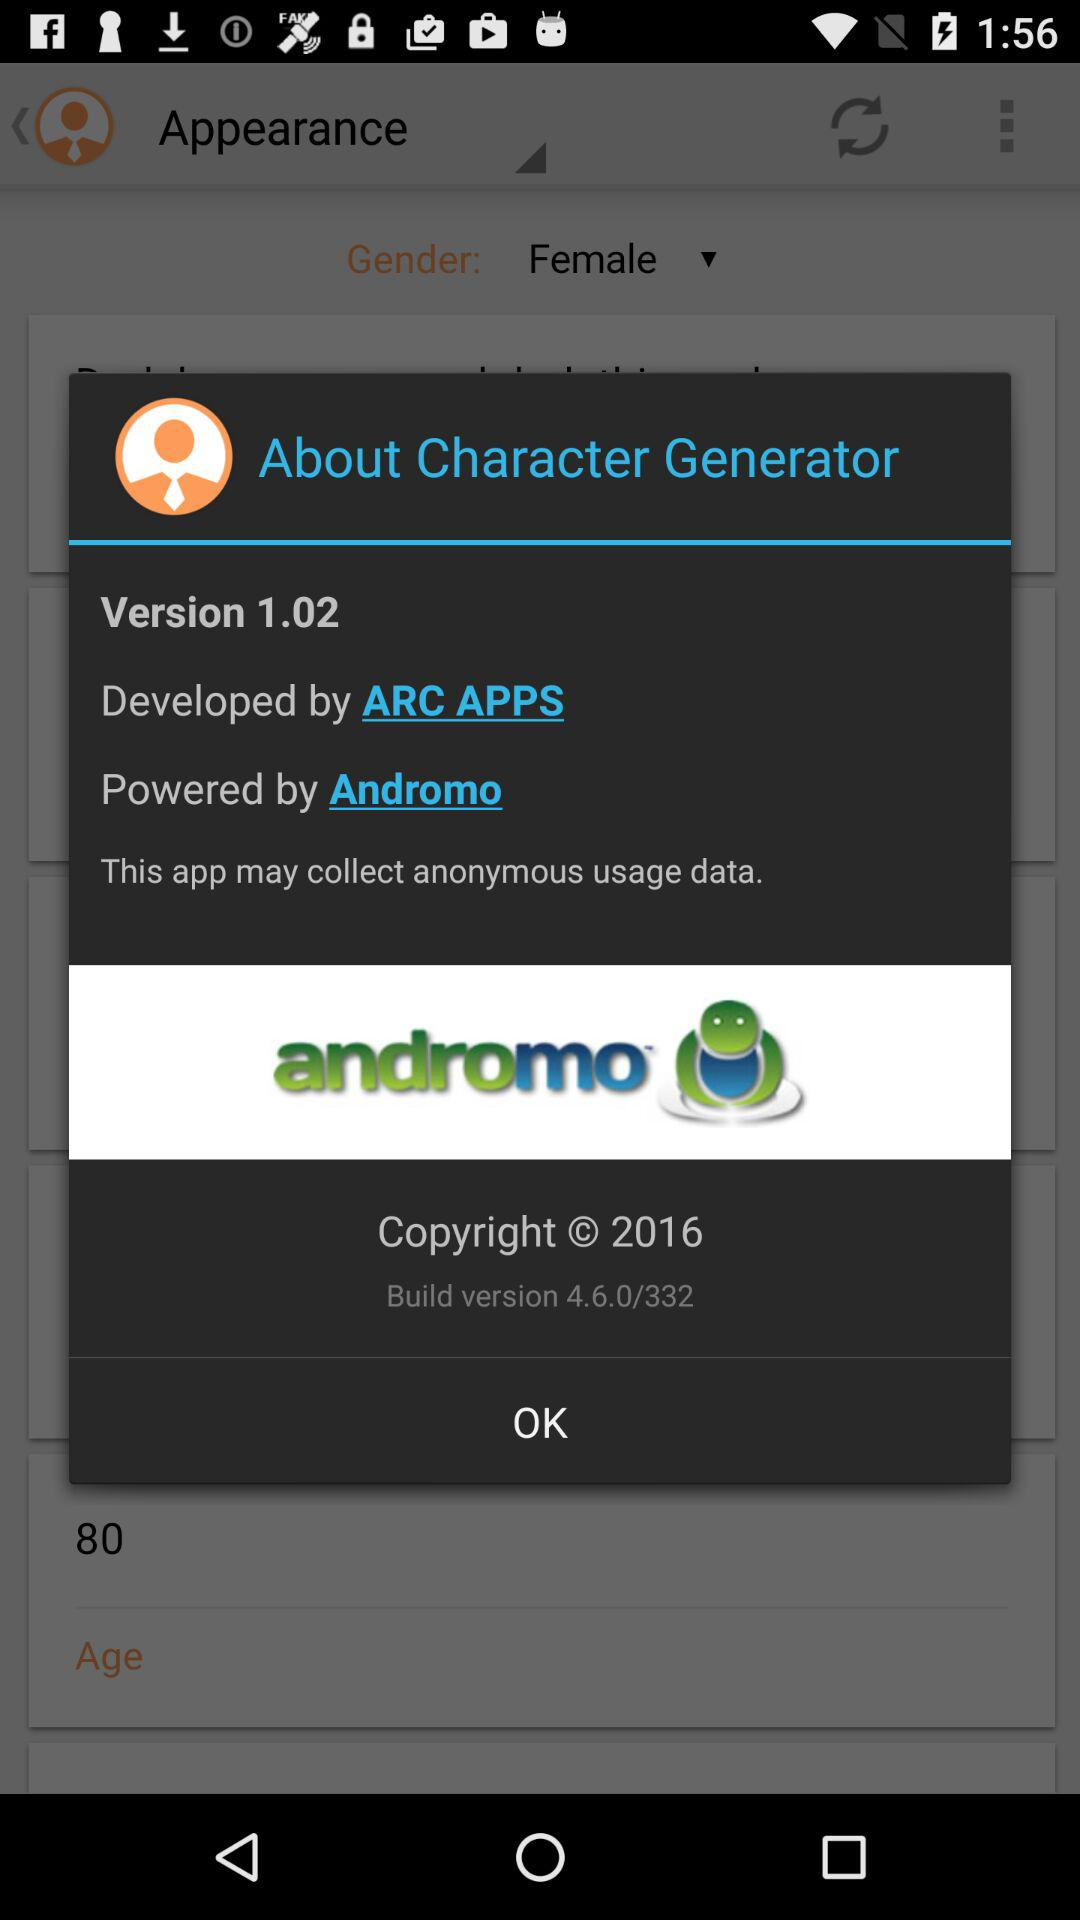Which company developed "Character Generator"? The "Character Generator" is developed by "ARC APPS". 